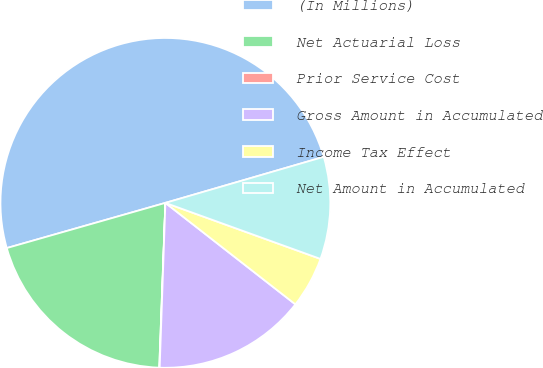<chart> <loc_0><loc_0><loc_500><loc_500><pie_chart><fcel>(In Millions)<fcel>Net Actuarial Loss<fcel>Prior Service Cost<fcel>Gross Amount in Accumulated<fcel>Income Tax Effect<fcel>Net Amount in Accumulated<nl><fcel>49.91%<fcel>19.99%<fcel>0.04%<fcel>15.0%<fcel>5.03%<fcel>10.02%<nl></chart> 